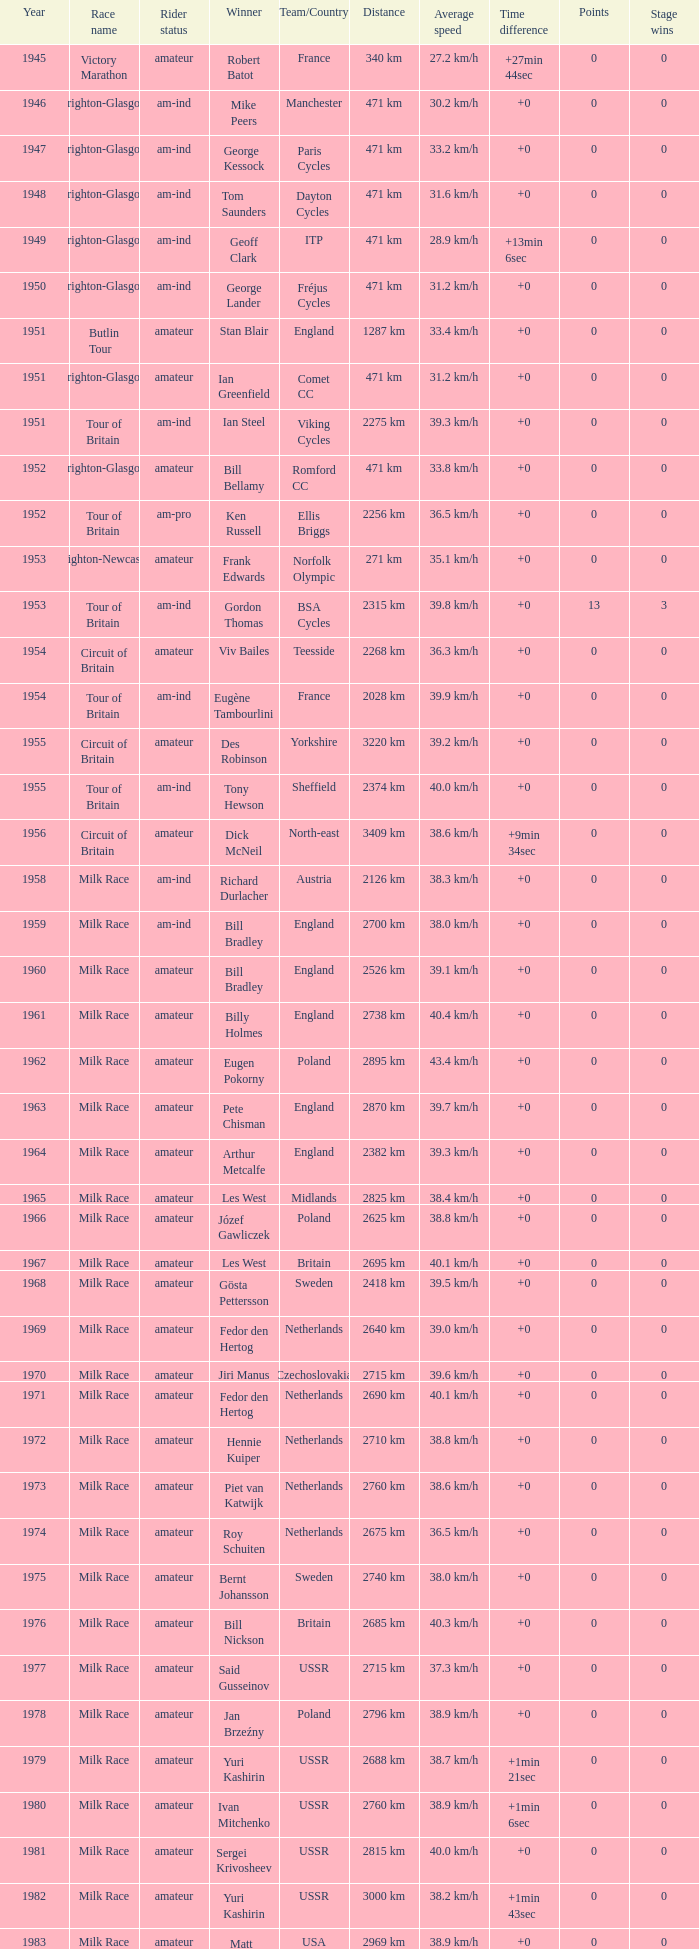What is the latest year when Phil Anderson won? 1993.0. 